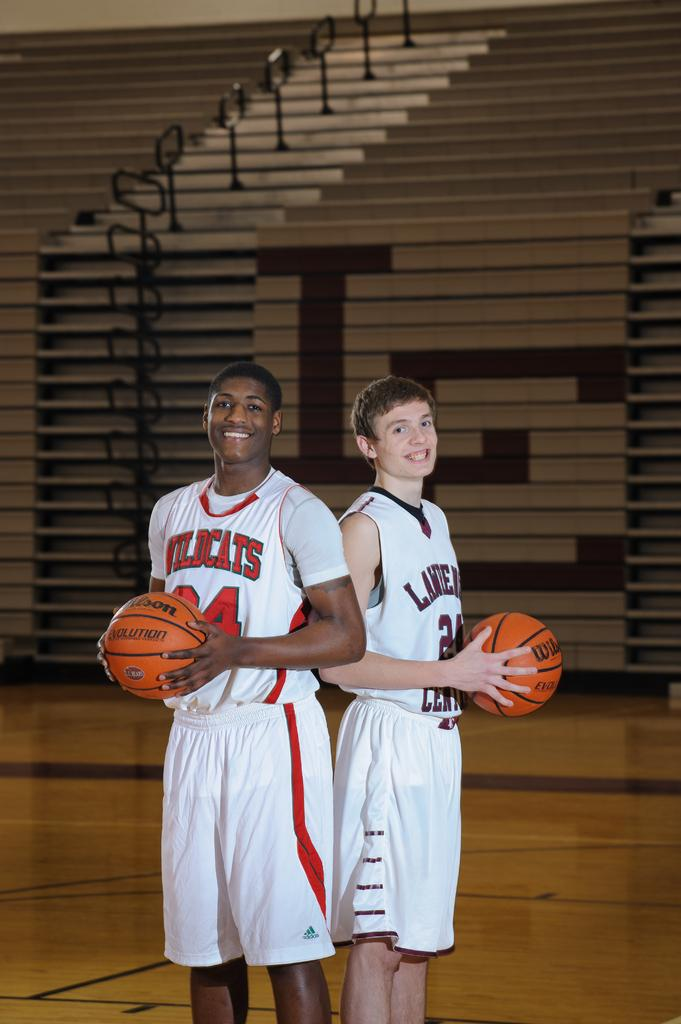<image>
Share a concise interpretation of the image provided. A guy wears a jersey with a Wildcats logo on it. 